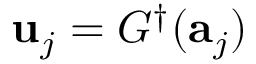Convert formula to latex. <formula><loc_0><loc_0><loc_500><loc_500>u _ { j } = G ^ { \dagger } ( a _ { j } )</formula> 